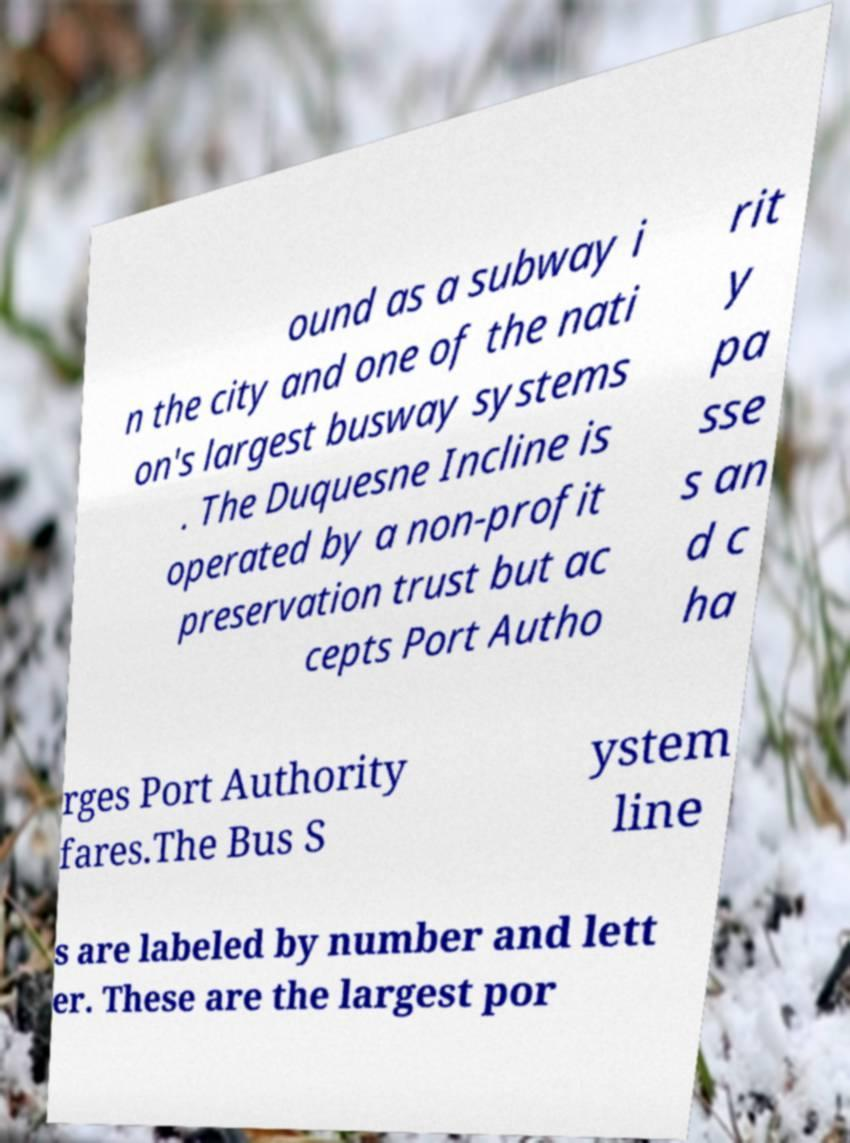Could you extract and type out the text from this image? ound as a subway i n the city and one of the nati on's largest busway systems . The Duquesne Incline is operated by a non-profit preservation trust but ac cepts Port Autho rit y pa sse s an d c ha rges Port Authority fares.The Bus S ystem line s are labeled by number and lett er. These are the largest por 